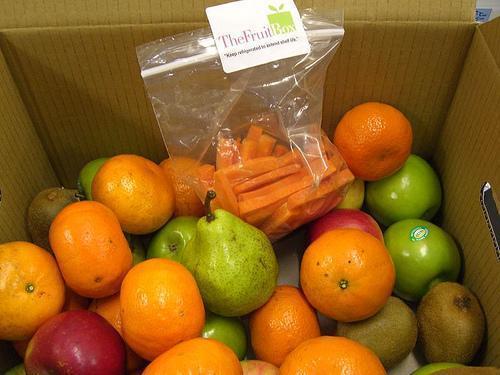How many kiwis in the box?
Give a very brief answer. 3. How many apples are in the photo?
Give a very brief answer. 2. How many oranges are visible?
Give a very brief answer. 9. 